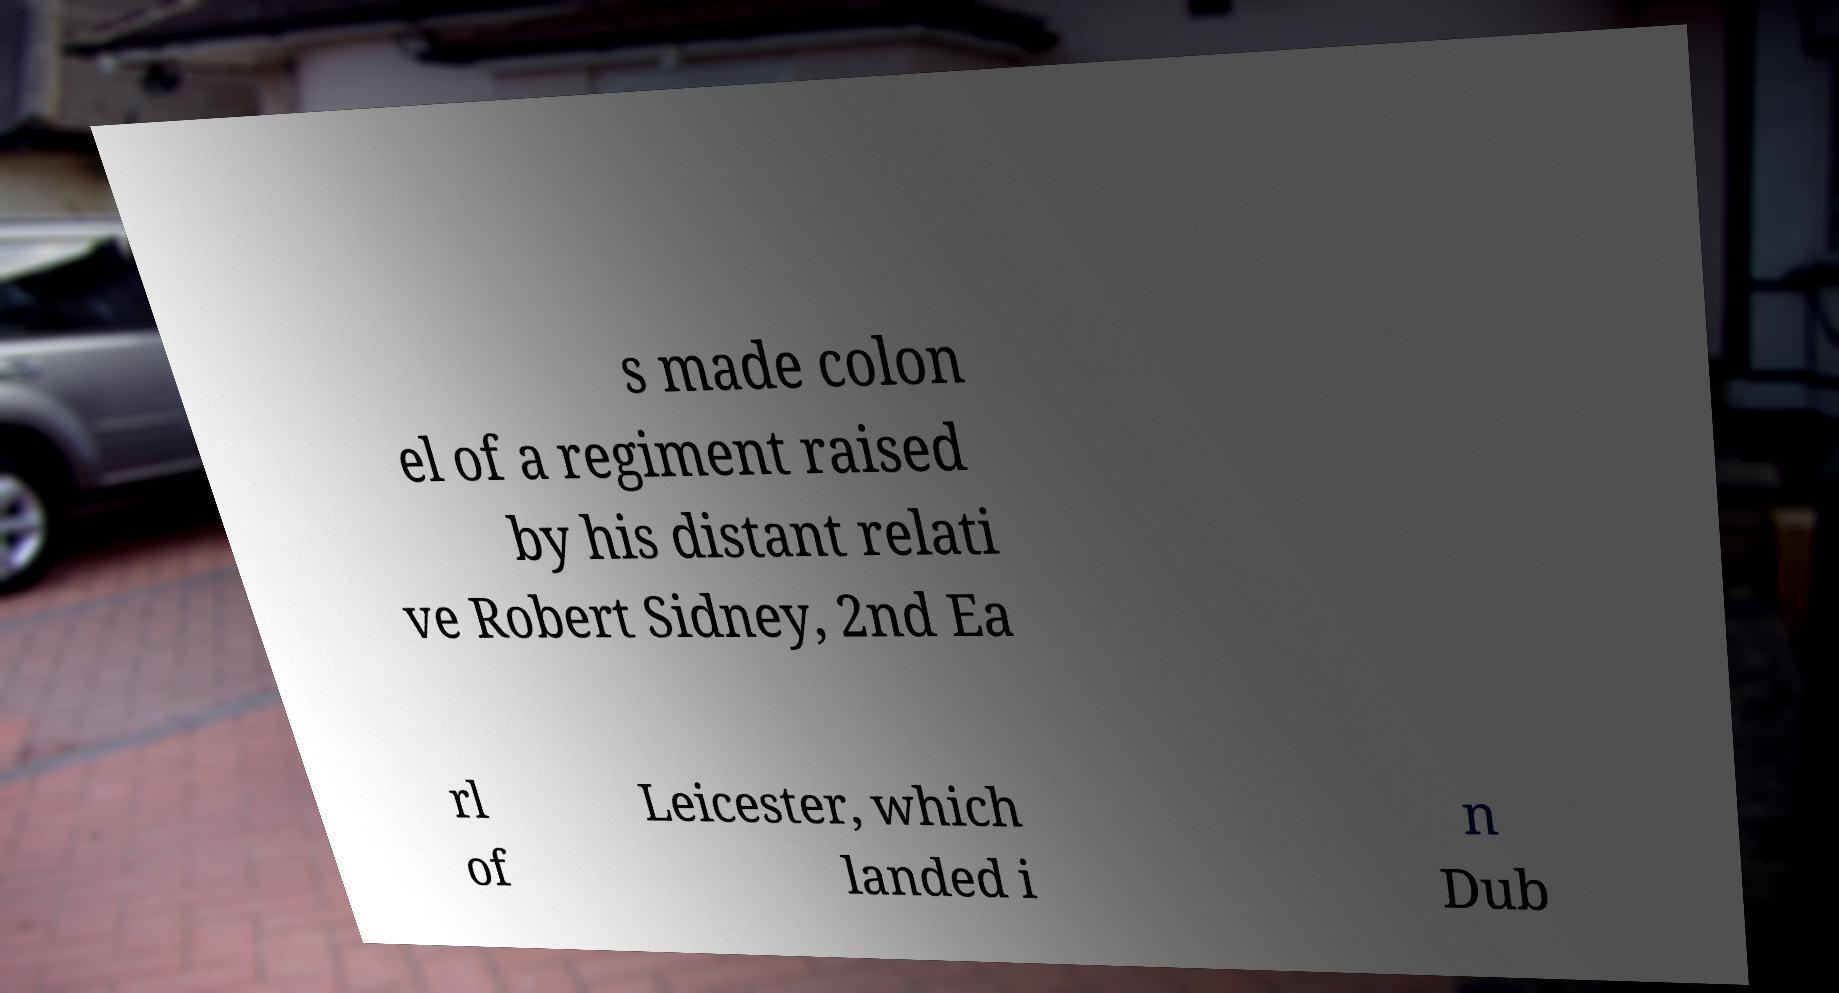Can you read and provide the text displayed in the image?This photo seems to have some interesting text. Can you extract and type it out for me? s made colon el of a regiment raised by his distant relati ve Robert Sidney, 2nd Ea rl of Leicester, which landed i n Dub 